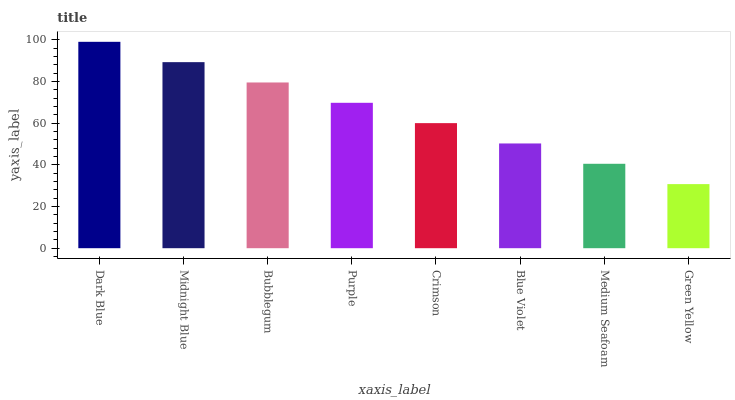Is Green Yellow the minimum?
Answer yes or no. Yes. Is Dark Blue the maximum?
Answer yes or no. Yes. Is Midnight Blue the minimum?
Answer yes or no. No. Is Midnight Blue the maximum?
Answer yes or no. No. Is Dark Blue greater than Midnight Blue?
Answer yes or no. Yes. Is Midnight Blue less than Dark Blue?
Answer yes or no. Yes. Is Midnight Blue greater than Dark Blue?
Answer yes or no. No. Is Dark Blue less than Midnight Blue?
Answer yes or no. No. Is Purple the high median?
Answer yes or no. Yes. Is Crimson the low median?
Answer yes or no. Yes. Is Crimson the high median?
Answer yes or no. No. Is Medium Seafoam the low median?
Answer yes or no. No. 